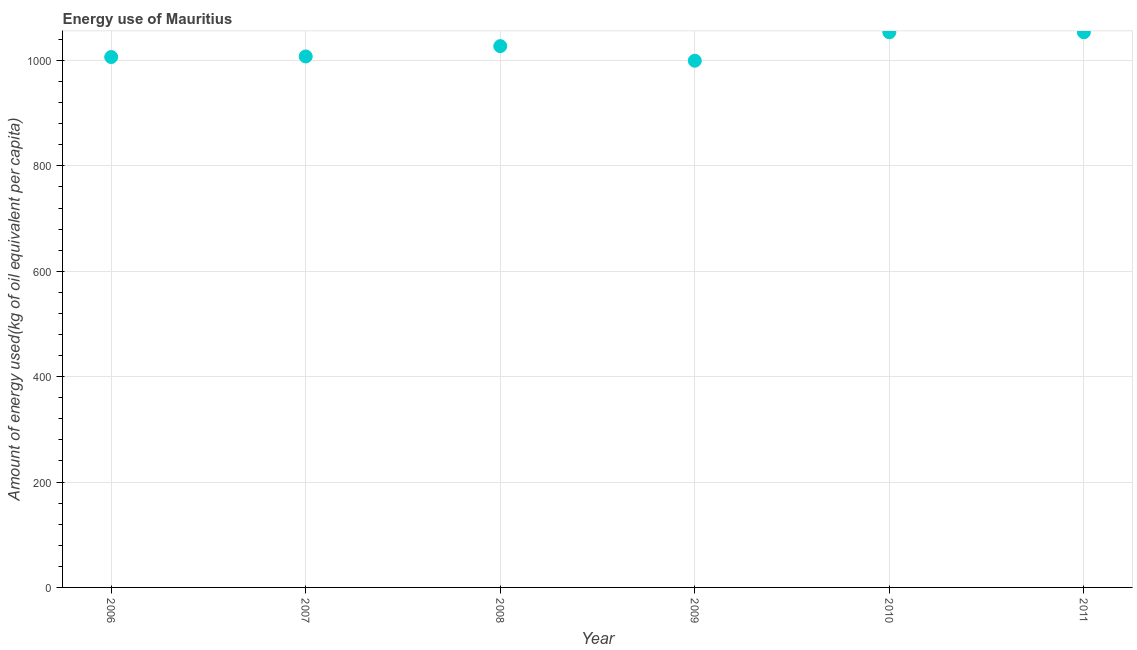What is the amount of energy used in 2006?
Your answer should be very brief. 1006.5. Across all years, what is the maximum amount of energy used?
Your response must be concise. 1053.51. Across all years, what is the minimum amount of energy used?
Offer a terse response. 999.49. In which year was the amount of energy used maximum?
Make the answer very short. 2011. What is the sum of the amount of energy used?
Your answer should be compact. 6147.7. What is the difference between the amount of energy used in 2007 and 2009?
Make the answer very short. 8.09. What is the average amount of energy used per year?
Your response must be concise. 1024.62. What is the median amount of energy used?
Keep it short and to the point. 1017.37. Do a majority of the years between 2011 and 2006 (inclusive) have amount of energy used greater than 720 kg?
Offer a terse response. Yes. What is the ratio of the amount of energy used in 2007 to that in 2011?
Your answer should be compact. 0.96. Is the amount of energy used in 2006 less than that in 2008?
Your response must be concise. Yes. What is the difference between the highest and the second highest amount of energy used?
Offer a terse response. 0.06. What is the difference between the highest and the lowest amount of energy used?
Your response must be concise. 54.02. Does the amount of energy used monotonically increase over the years?
Ensure brevity in your answer.  No. What is the difference between two consecutive major ticks on the Y-axis?
Your answer should be compact. 200. Does the graph contain any zero values?
Provide a short and direct response. No. What is the title of the graph?
Give a very brief answer. Energy use of Mauritius. What is the label or title of the Y-axis?
Provide a succinct answer. Amount of energy used(kg of oil equivalent per capita). What is the Amount of energy used(kg of oil equivalent per capita) in 2006?
Keep it short and to the point. 1006.5. What is the Amount of energy used(kg of oil equivalent per capita) in 2007?
Your answer should be compact. 1007.57. What is the Amount of energy used(kg of oil equivalent per capita) in 2008?
Provide a succinct answer. 1027.17. What is the Amount of energy used(kg of oil equivalent per capita) in 2009?
Offer a terse response. 999.49. What is the Amount of energy used(kg of oil equivalent per capita) in 2010?
Make the answer very short. 1053.45. What is the Amount of energy used(kg of oil equivalent per capita) in 2011?
Your answer should be very brief. 1053.51. What is the difference between the Amount of energy used(kg of oil equivalent per capita) in 2006 and 2007?
Ensure brevity in your answer.  -1.07. What is the difference between the Amount of energy used(kg of oil equivalent per capita) in 2006 and 2008?
Provide a short and direct response. -20.67. What is the difference between the Amount of energy used(kg of oil equivalent per capita) in 2006 and 2009?
Ensure brevity in your answer.  7.01. What is the difference between the Amount of energy used(kg of oil equivalent per capita) in 2006 and 2010?
Your answer should be compact. -46.95. What is the difference between the Amount of energy used(kg of oil equivalent per capita) in 2006 and 2011?
Give a very brief answer. -47.01. What is the difference between the Amount of energy used(kg of oil equivalent per capita) in 2007 and 2008?
Offer a very short reply. -19.6. What is the difference between the Amount of energy used(kg of oil equivalent per capita) in 2007 and 2009?
Keep it short and to the point. 8.09. What is the difference between the Amount of energy used(kg of oil equivalent per capita) in 2007 and 2010?
Your response must be concise. -45.88. What is the difference between the Amount of energy used(kg of oil equivalent per capita) in 2007 and 2011?
Make the answer very short. -45.94. What is the difference between the Amount of energy used(kg of oil equivalent per capita) in 2008 and 2009?
Your answer should be compact. 27.69. What is the difference between the Amount of energy used(kg of oil equivalent per capita) in 2008 and 2010?
Your answer should be very brief. -26.28. What is the difference between the Amount of energy used(kg of oil equivalent per capita) in 2008 and 2011?
Your answer should be very brief. -26.34. What is the difference between the Amount of energy used(kg of oil equivalent per capita) in 2009 and 2010?
Offer a very short reply. -53.97. What is the difference between the Amount of energy used(kg of oil equivalent per capita) in 2009 and 2011?
Offer a terse response. -54.02. What is the difference between the Amount of energy used(kg of oil equivalent per capita) in 2010 and 2011?
Offer a very short reply. -0.06. What is the ratio of the Amount of energy used(kg of oil equivalent per capita) in 2006 to that in 2008?
Ensure brevity in your answer.  0.98. What is the ratio of the Amount of energy used(kg of oil equivalent per capita) in 2006 to that in 2010?
Offer a terse response. 0.95. What is the ratio of the Amount of energy used(kg of oil equivalent per capita) in 2006 to that in 2011?
Give a very brief answer. 0.95. What is the ratio of the Amount of energy used(kg of oil equivalent per capita) in 2007 to that in 2010?
Provide a short and direct response. 0.96. What is the ratio of the Amount of energy used(kg of oil equivalent per capita) in 2007 to that in 2011?
Offer a very short reply. 0.96. What is the ratio of the Amount of energy used(kg of oil equivalent per capita) in 2008 to that in 2009?
Your response must be concise. 1.03. What is the ratio of the Amount of energy used(kg of oil equivalent per capita) in 2009 to that in 2010?
Make the answer very short. 0.95. What is the ratio of the Amount of energy used(kg of oil equivalent per capita) in 2009 to that in 2011?
Your answer should be compact. 0.95. 